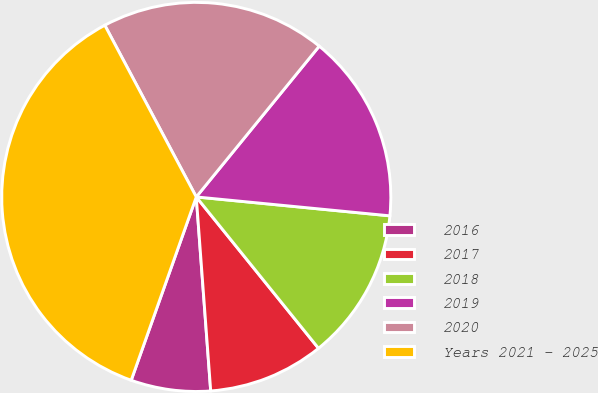Convert chart. <chart><loc_0><loc_0><loc_500><loc_500><pie_chart><fcel>2016<fcel>2017<fcel>2018<fcel>2019<fcel>2020<fcel>Years 2021 - 2025<nl><fcel>6.61%<fcel>9.63%<fcel>12.64%<fcel>15.66%<fcel>18.68%<fcel>36.78%<nl></chart> 